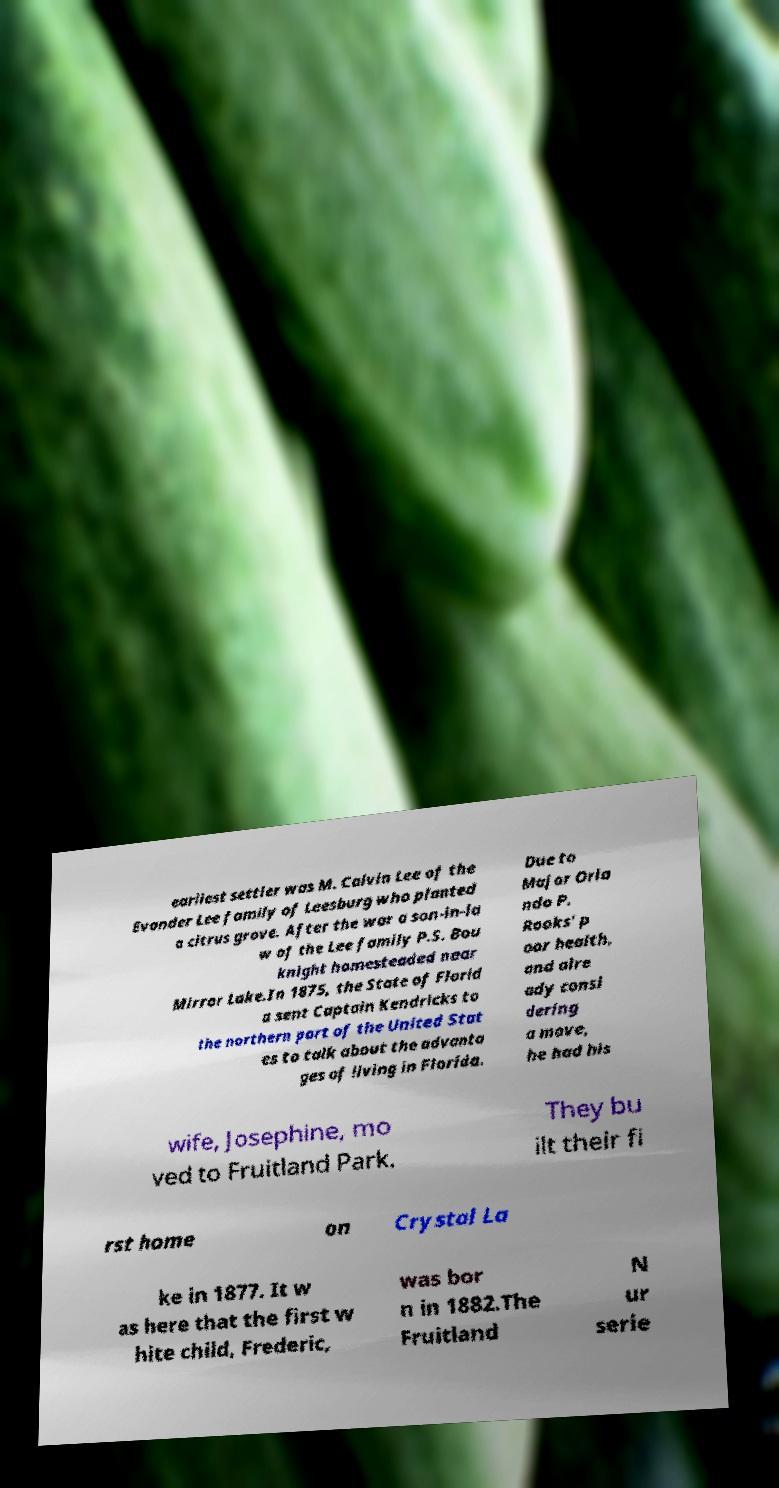Please identify and transcribe the text found in this image. earliest settler was M. Calvin Lee of the Evander Lee family of Leesburg who planted a citrus grove. After the war a son-in-la w of the Lee family P.S. Bou knight homesteaded near Mirror Lake.In 1875, the State of Florid a sent Captain Kendricks to the northern part of the United Stat es to talk about the advanta ges of living in Florida. Due to Major Orla ndo P. Rooks' p oor health, and alre ady consi dering a move, he had his wife, Josephine, mo ved to Fruitland Park. They bu ilt their fi rst home on Crystal La ke in 1877. It w as here that the first w hite child, Frederic, was bor n in 1882.The Fruitland N ur serie 